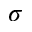Convert formula to latex. <formula><loc_0><loc_0><loc_500><loc_500>\sigma</formula> 